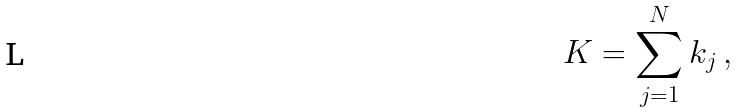Convert formula to latex. <formula><loc_0><loc_0><loc_500><loc_500>K = \sum _ { j = 1 } ^ { N } k _ { j } \, ,</formula> 